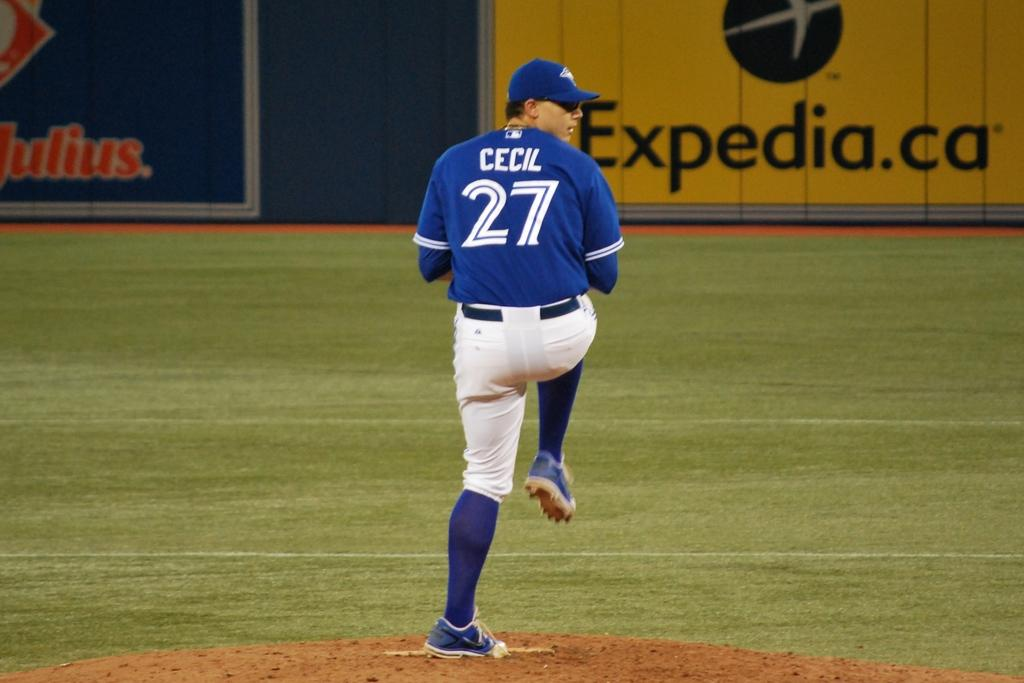What is the primary subject in the image? There is a person standing in the image. Where is the person standing? The person is standing on the ground. What can be seen in the background of the image? There are boards visible in the background of the image. What type of sand can be seen on the ground where the person is standing? There is no sand visible in the image; the person is standing on the ground, which appears to be a solid surface. 